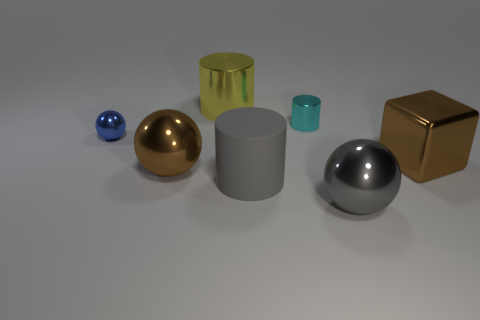Subtract all metallic cylinders. How many cylinders are left? 1 Add 2 tiny metal things. How many objects exist? 9 Subtract all yellow cylinders. How many cylinders are left? 2 Subtract all cubes. How many objects are left? 6 Subtract 1 cylinders. How many cylinders are left? 2 Subtract all brown objects. Subtract all big objects. How many objects are left? 0 Add 7 big gray cylinders. How many big gray cylinders are left? 8 Add 1 yellow cylinders. How many yellow cylinders exist? 2 Subtract 0 purple balls. How many objects are left? 7 Subtract all cyan cubes. Subtract all yellow cylinders. How many cubes are left? 1 